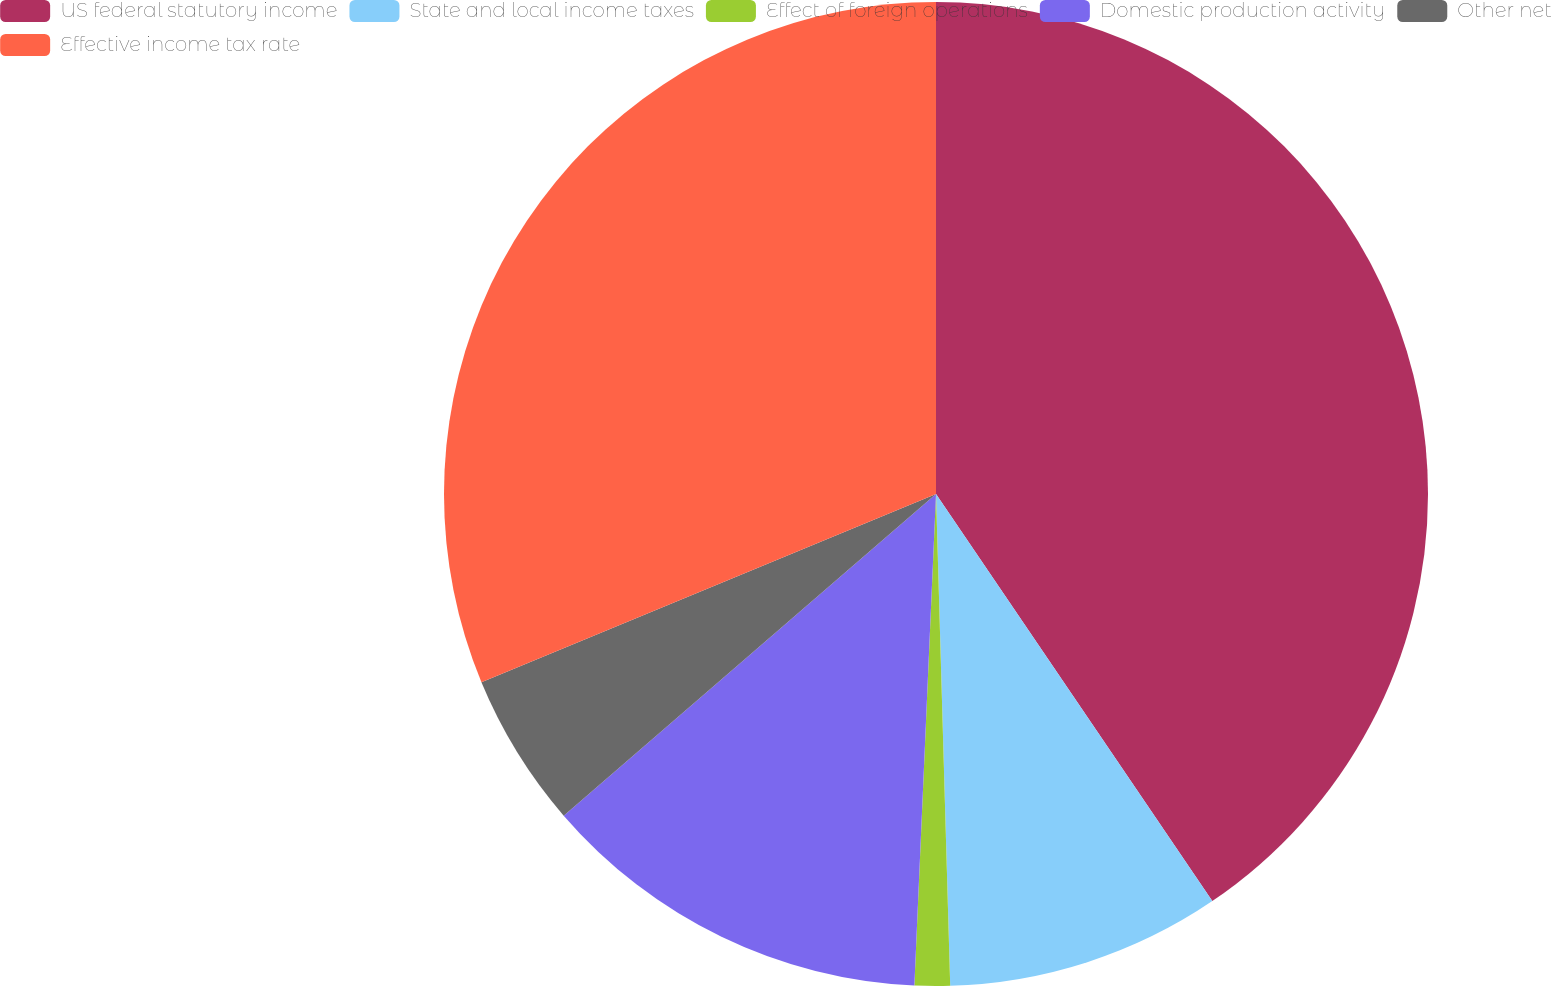<chart> <loc_0><loc_0><loc_500><loc_500><pie_chart><fcel>US federal statutory income<fcel>State and local income taxes<fcel>Effect of foreign operations<fcel>Domestic production activity<fcel>Other net<fcel>Effective income tax rate<nl><fcel>40.51%<fcel>9.03%<fcel>1.16%<fcel>12.96%<fcel>5.09%<fcel>31.25%<nl></chart> 